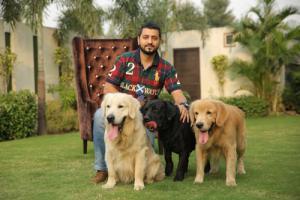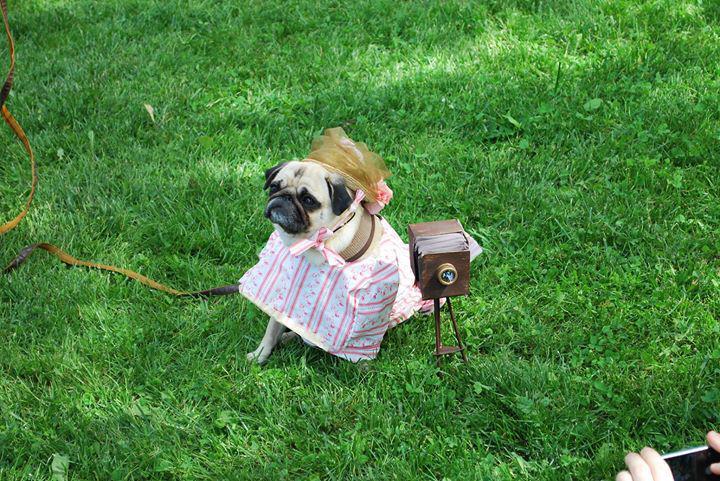The first image is the image on the left, the second image is the image on the right. Assess this claim about the two images: "Three buff-beige pugs are side-by-side on the grass in one image, and one dog standing and wearing a collar is in the other image.". Correct or not? Answer yes or no. No. The first image is the image on the left, the second image is the image on the right. Analyze the images presented: Is the assertion "The right image contains no more than one dog." valid? Answer yes or no. Yes. 